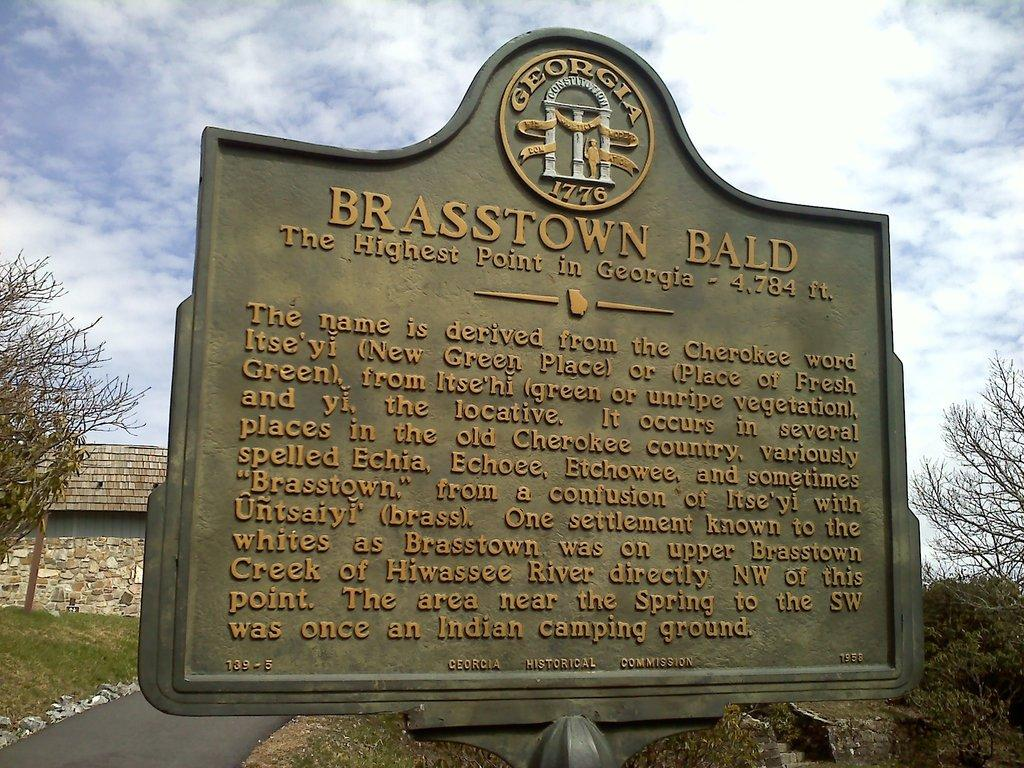What is the main object in the image? There is a board in the image. What can be seen on the ground in the image? There are stones on a path in the image. What is visible in the background of the image? There is a compound wall, a building, and trees in the background of the image. What color is the frog sitting on the drum in the image? There is no frog or drum present in the image. 